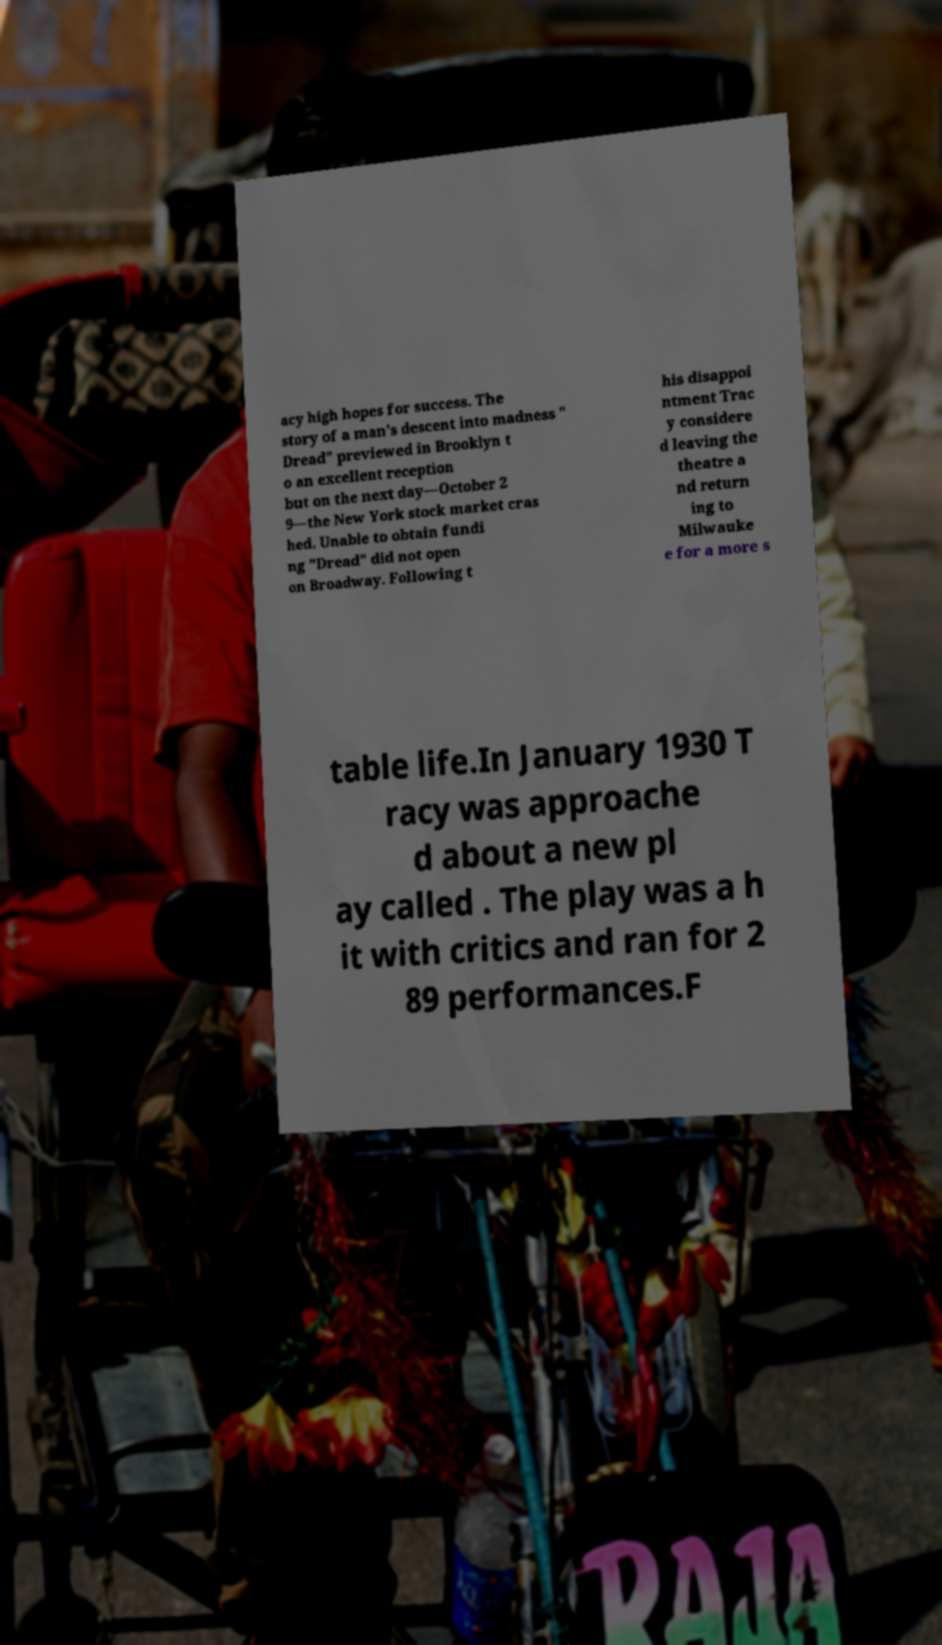Please identify and transcribe the text found in this image. acy high hopes for success. The story of a man's descent into madness " Dread" previewed in Brooklyn t o an excellent reception but on the next day—October 2 9—the New York stock market cras hed. Unable to obtain fundi ng "Dread" did not open on Broadway. Following t his disappoi ntment Trac y considere d leaving the theatre a nd return ing to Milwauke e for a more s table life.In January 1930 T racy was approache d about a new pl ay called . The play was a h it with critics and ran for 2 89 performances.F 